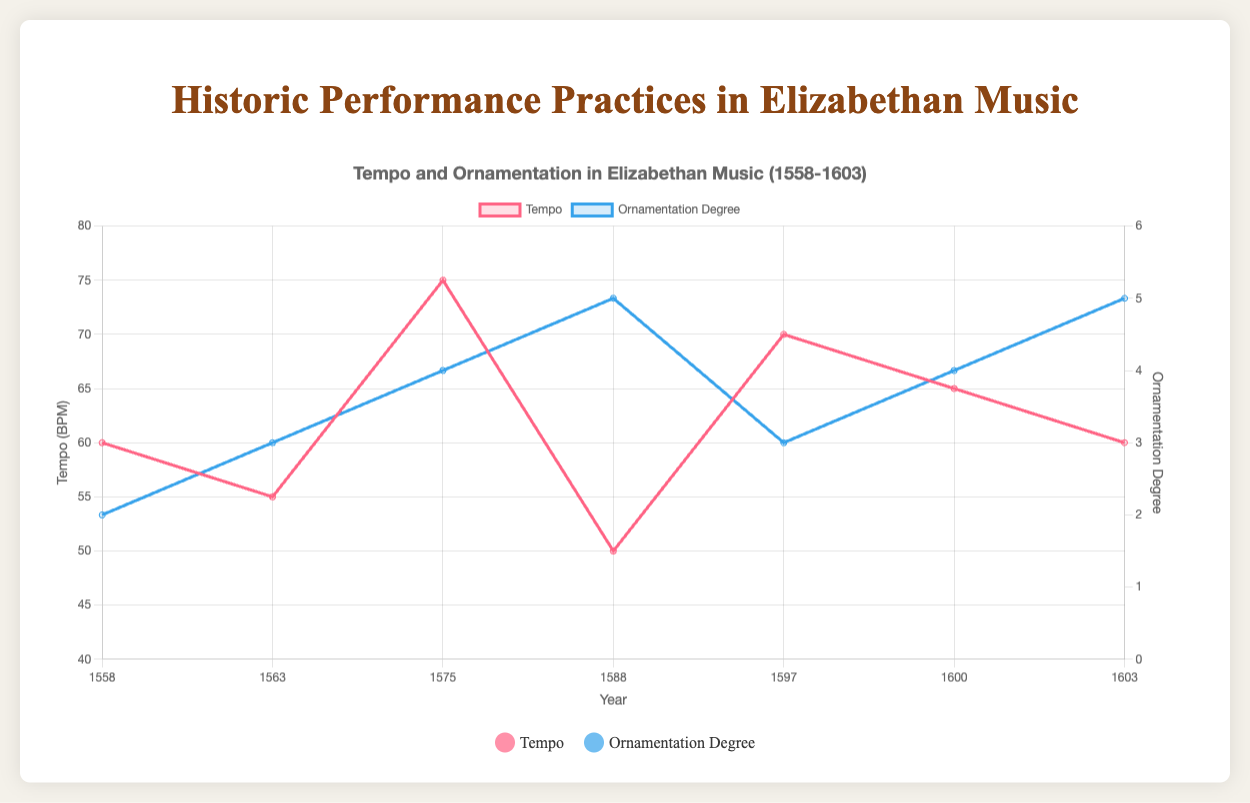What is the overall trend in tempo from 1558 to 1603? The tempo starts at 60 BPM in 1558 and decreases to 55 BPM in 1563. It then increases to 75 BPM by 1575, decreases again to 50 BPM in 1588, increases to 70 BPM in 1597, and finally fluctuates slightly to 65 BPM in 1600 and 60 BPM in 1603. So, the overall trend is fluctuating rather than linear.
Answer: Fluctuating Which composer used the highest degree of ornamentation in their piece? Referring to the plot, John Dowland's pieces in 1588 and 1603 have the highest ornamentation degree of 5.
Answer: John Dowland Comparing the tempo in 1558 and 1575, which year had a higher tempo? The plot shows that in 1558, the tempo was 60 BPM, whereas in 1575, the tempo was 75 BPM.
Answer: 1575 How does the ornamentation degree for William Byrd's piece compare to Thomas Weelkes' piece? The ornamentation degree for William Byrd's piece in 1563 is 3, and for Thomas Weelkes' piece in 1597, it is also 3. They are equal.
Answer: Equal What are the average tempo and average ornamentation degree of all the pieces from John Dowland? The tempos for John Dowland's pieces are 50 BPM in 1588 and 60 BPM in 1603. So, the average tempo is (50 + 60) / 2 = 55 BPM. The ornamentation degrees are 5 and 5, so the average is (5 + 5) / 2 = 5.
Answer: Average tempo: 55 BPM, Average ornamentation degree: 5 Which piece has the lowest tempo, and what is its ornamentation degree? The piece "Flow my tears" by John Dowland in 1588 has the lowest tempo of 50 BPM. The ornamentation degree for this piece is 5.
Answer: "Flow my tears", 5 Calculate the total change in tempo between all pieces from 1558 to 1603. The changes in tempo are: -5 (1558 to 1563), +20 (1563 to 1575), -25 (1575 to 1588), +20 (1588 to 1597), -5 (1597 to 1600), -5 (1600 to 1603). Summing these changes: -5 + 20 - 25 + 20 - 5 - 5 = 0.
Answer: 0 For which years did the ornamentation degree increase compared to the previous recorded year? The ornamentation degree increased from 2 to 3 (1558 to 1563), 3 to 4 (1563 to 1575), and from 4 to 5 (1575 to 1588).
Answer: 1563, 1575, 1588 What is the average vibrato usage across all pieces? Analyzing the vibrato usage categorically: "rare" appears 4 times, "moderate" appears 2 times, and "high" appears 2 times. The average could be considered as the mode, which is the most frequent value.
Answer: rare 